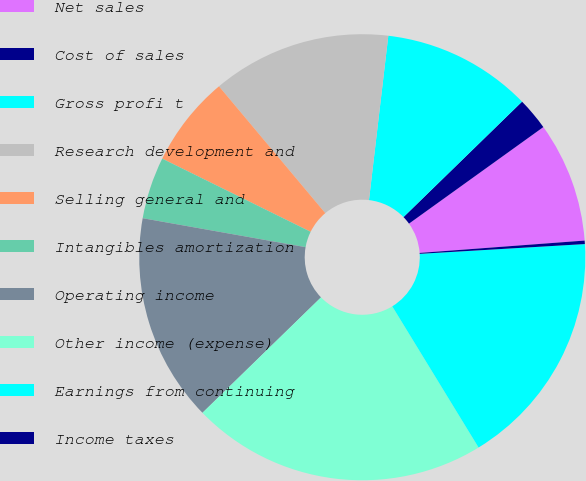<chart> <loc_0><loc_0><loc_500><loc_500><pie_chart><fcel>Net sales<fcel>Cost of sales<fcel>Gross profi t<fcel>Research development and<fcel>Selling general and<fcel>Intangibles amortization<fcel>Operating income<fcel>Other income (expense)<fcel>Earnings from continuing<fcel>Income taxes<nl><fcel>8.73%<fcel>2.37%<fcel>10.85%<fcel>12.97%<fcel>6.61%<fcel>4.49%<fcel>15.09%<fcel>21.45%<fcel>17.21%<fcel>0.25%<nl></chart> 